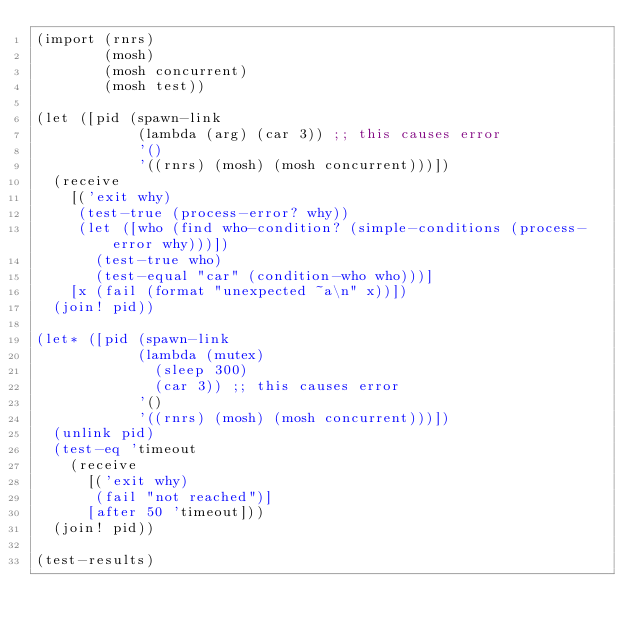Convert code to text. <code><loc_0><loc_0><loc_500><loc_500><_Scheme_>(import (rnrs)
        (mosh)
        (mosh concurrent)
        (mosh test))

(let ([pid (spawn-link
            (lambda (arg) (car 3)) ;; this causes error
            '()
            '((rnrs) (mosh) (mosh concurrent)))])
  (receive
    [('exit why)
     (test-true (process-error? why))
     (let ([who (find who-condition? (simple-conditions (process-error why)))])
       (test-true who)
       (test-equal "car" (condition-who who)))]
    [x (fail (format "unexpected ~a\n" x))])
  (join! pid))

(let* ([pid (spawn-link
            (lambda (mutex)
              (sleep 300)
              (car 3)) ;; this causes error
            '()
            '((rnrs) (mosh) (mosh concurrent)))])
  (unlink pid)
  (test-eq 'timeout
    (receive
      [('exit why)
       (fail "not reached")]
      [after 50 'timeout]))
  (join! pid))

(test-results)
</code> 